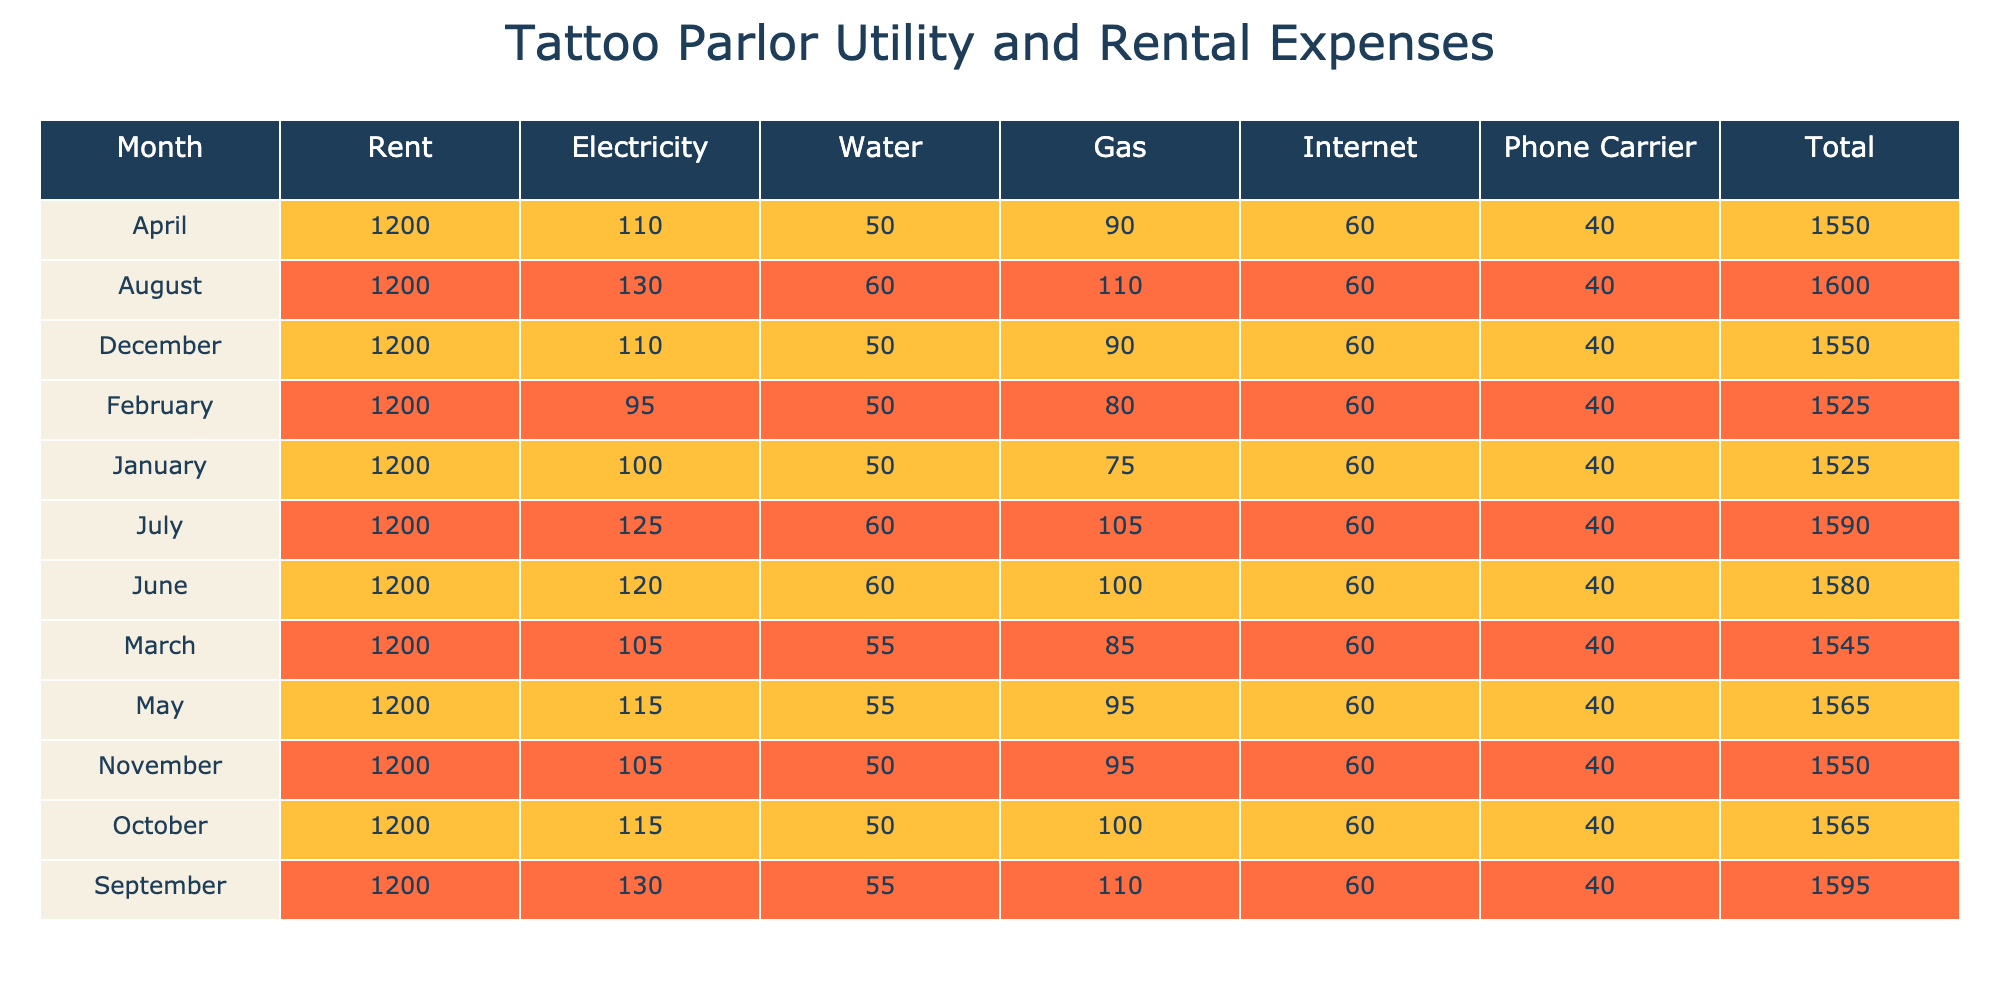What is the total amount spent on rent in January? The amount spent on rent in January is listed as 1200 USD in the table, which is specific to that month.
Answer: 1200 USD What was the electricity expense for June? The table shows that the electricity expense for June is 120 USD, which is noted in the corresponding row.
Answer: 120 USD Is the phone carrier expense consistent throughout the year? Reviewing the phone carrier expenses for each month in the table, it shows that the amount of 40 USD is consistent for each month.
Answer: Yes What is the average gas expense for the first quarter? To find the average gas expense for January, February, and March, sum the amounts: 75 (Jan) + 80 (Feb) + 85 (Mar) = 240 USD. There are 3 months, so the average is 240 / 3 = 80 USD.
Answer: 80 USD Which month had the highest total utility expense? To determine the month with the highest total utility expense, calculate the totals for each month by summing all expenses. January total is 1505 USD, February is 1495 USD, March is 1490 USD, and the rest follow similarly. The highest total is for January at 1505 USD.
Answer: January What was the difference in total utility expenses between September and December? First, find the total for September, which is 1465 USD, and for December, which is 1450 USD. The difference is 1465 - 1450 = 15 USD.
Answer: 15 USD What is the percentage increase in electricity expense from January to July? The electricity expense in January is 100 USD, and in July it is 125 USD. The increase is 125 - 100 = 25 USD. To find the percentage increase: (25 / 100) * 100 = 25%.
Answer: 25% How many utility types had expenses of 60 USD in June? Looking at the table for June, the utilities with an expense of 60 USD are Water, Internet, and Phone Carrier. That is a total of 3 types.
Answer: 3 Was there any month where the gas expense exceeded 100 USD? Checking the gas expenses from the table, the amounts are 75, 80, 85, 90, 95, 100, 105, 110, and in September and October it remains at 110 and 100 respectively. Therefore, yes, July and August had expenses exceeding 100 USD.
Answer: Yes 